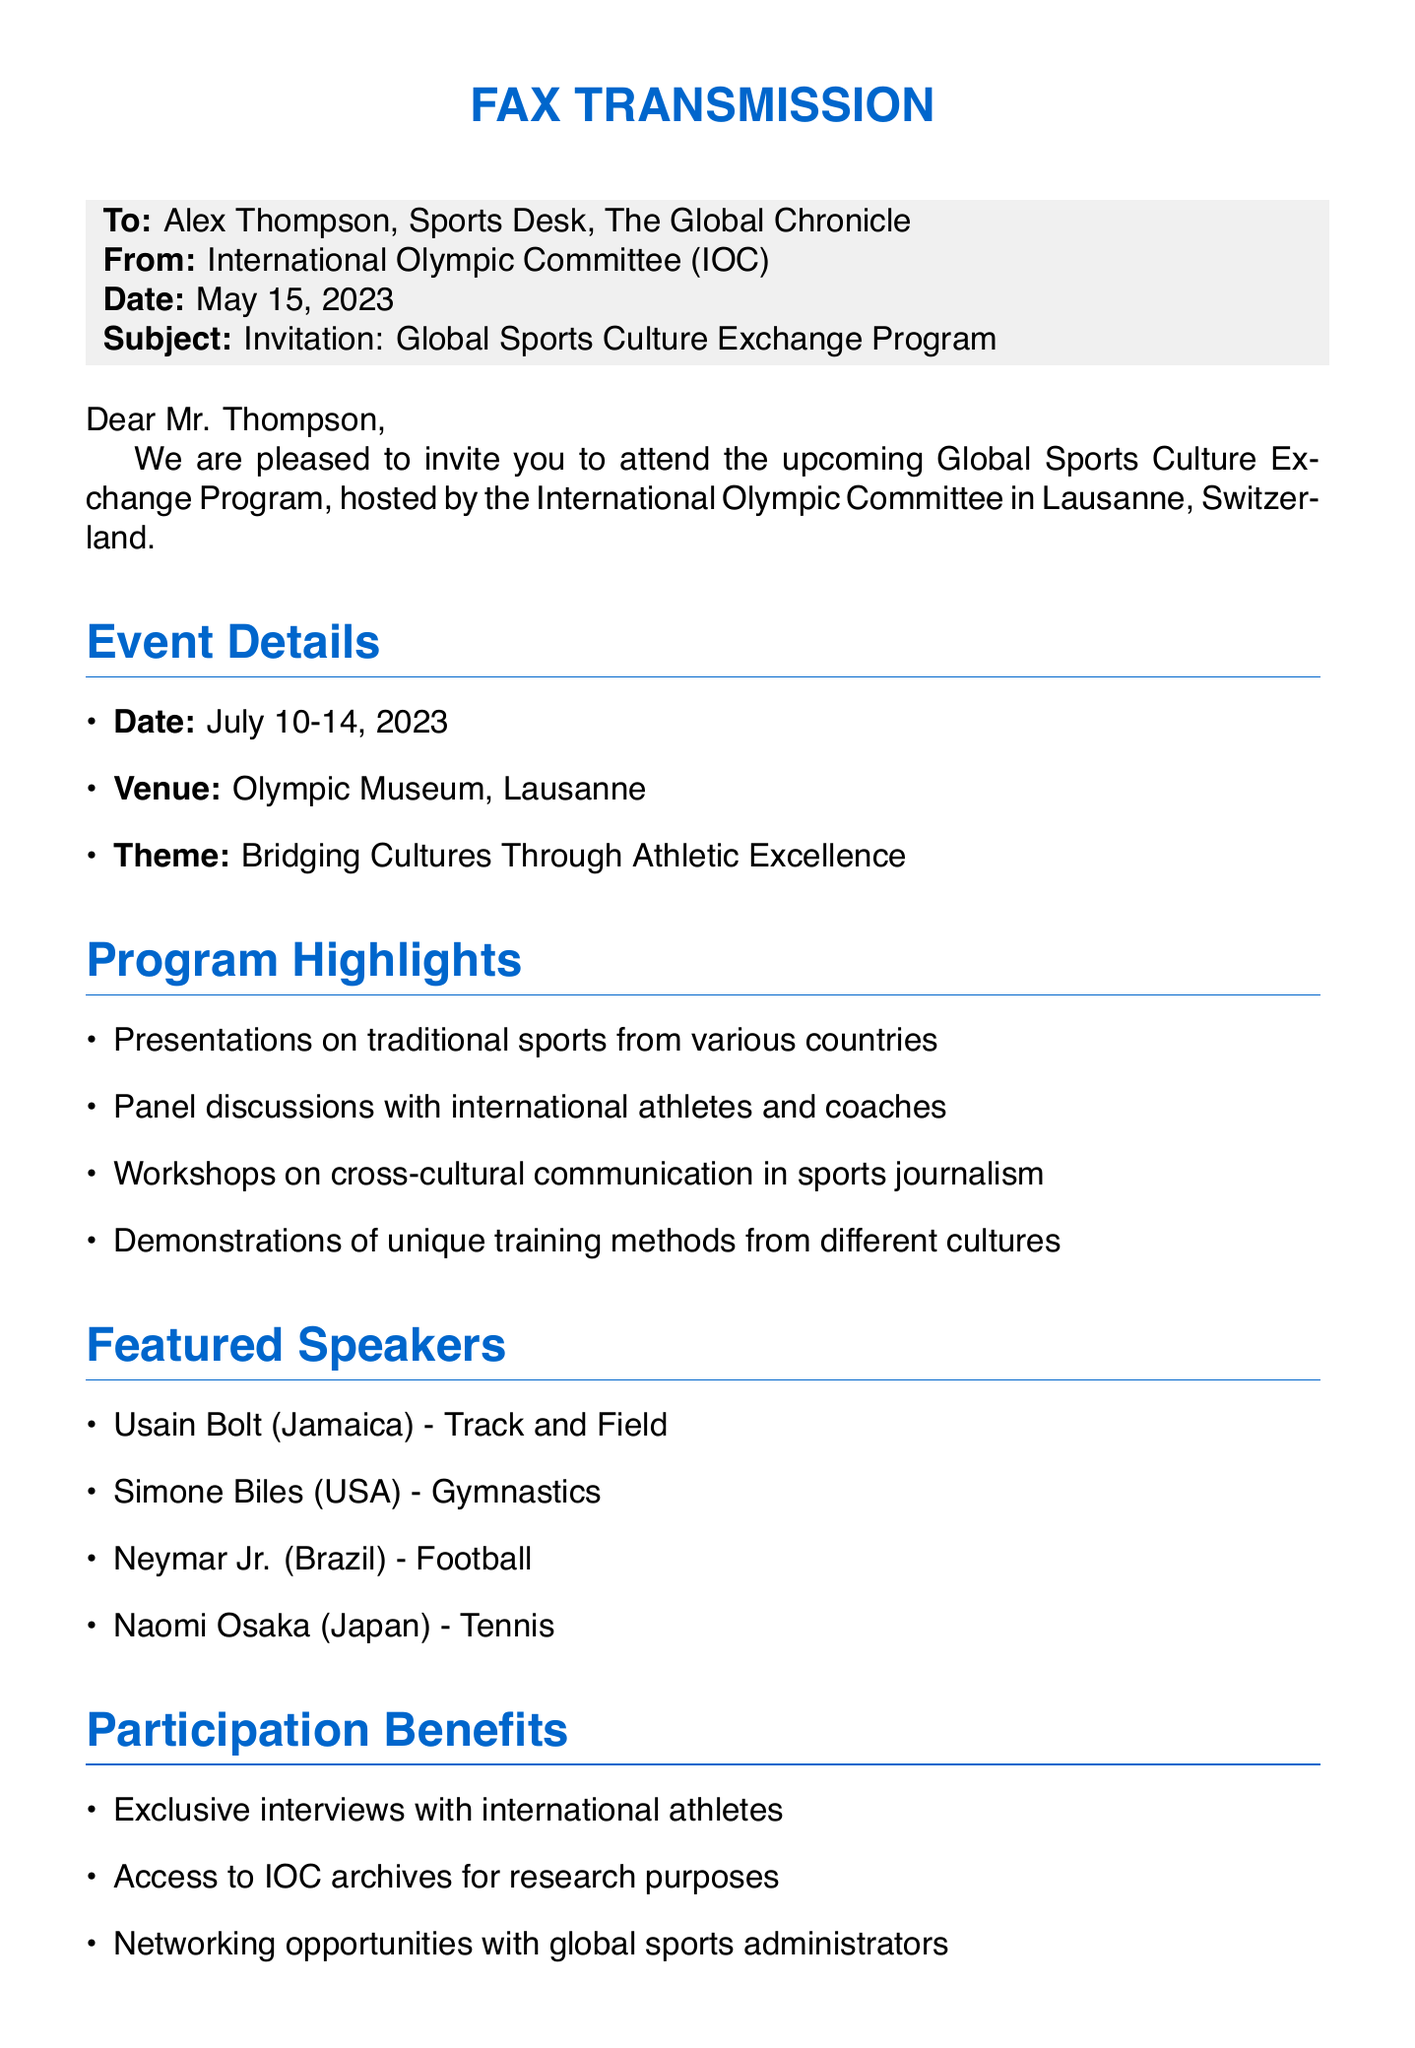What is the date of the event? The event is scheduled for July 10-14, 2023, as mentioned in the event details section.
Answer: July 10-14, 2023 Who is the sender of the fax? The fax is sent by the International Olympic Committee, indicated in the "From" section.
Answer: International Olympic Committee (IOC) What is the venue for the program? The venue is specified as the Olympic Museum, Lausanne, in the event details.
Answer: Olympic Museum, Lausanne When is the RSVP deadline? The RSVP deadline is mentioned as June 1, 2023, in the RSVP instructions section.
Answer: June 1, 2023 What is the theme of the program? The theme "Bridging Cultures Through Athletic Excellence" is stated in the event details section.
Answer: Bridging Cultures Through Athletic Excellence Which athlete is featured from Japan? Naomi Osaka is listed as the featured speaker from Japan in the featured speakers section.
Answer: Naomi Osaka What type of discussions will occur during the program? Panel discussions with international athletes and coaches are highlighted in the program highlights.
Answer: Panel discussions Who should be contacted for RSVP? Emily Chen is mentioned as the contact person for RSVP in the RSVP instructions.
Answer: Emily Chen 